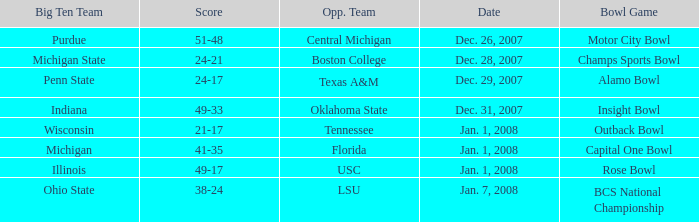How did the bcs national championship game conclude in terms of scoring? 38-24. 